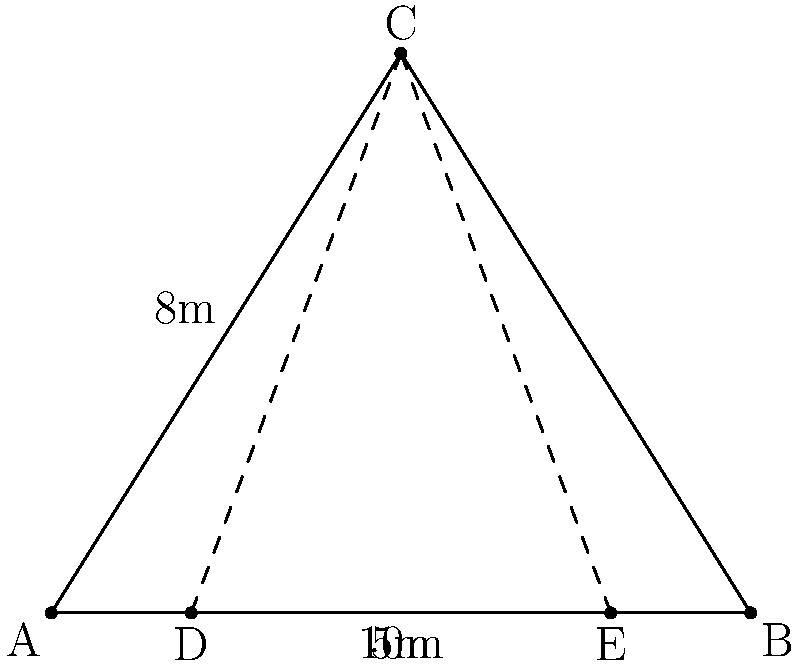In a custom-built car showcase room, a prized vehicle is positioned at point C in an elevated display. The room has a triangular layout with dimensions AB = 10m, AC = 8m, and angle CAB = 90°. Two VIP seats are located at points D and E, 2m from each end of the base. What is the optimal viewing angle DCE for the VIP guests, and how does this setup maximize the visual impact of the showcase? Let's approach this step-by-step:

1) First, we need to find the coordinates of points C, D, and E.
   - A is at (0,0), B at (10,0)
   - C forms a right triangle with AB, so its coordinates are (5,8)
   - D is 2m from A, so it's at (2,0)
   - E is 2m from B, so it's at (8,0)

2) To find angle DCE, we can use the dot product formula:
   $\cos(\theta) = \frac{\vec{CD} \cdot \vec{CE}}{|\vec{CD}||\vec{CE}|}$

3) Calculate vectors $\vec{CD}$ and $\vec{CE}$:
   $\vec{CD} = (2-5, 0-8) = (-3, -8)$
   $\vec{CE} = (8-5, 0-8) = (3, -8)$

4) Calculate dot product $\vec{CD} \cdot \vec{CE}$:
   $(-3)(3) + (-8)(-8) = -9 + 64 = 55$

5) Calculate magnitudes:
   $|\vec{CD}| = |\vec{CE}| = \sqrt{3^2 + 8^2} = \sqrt{73}$

6) Apply the formula:
   $\cos(\theta) = \frac{55}{73} \approx 0.7534$

7) Take the inverse cosine (arccos) to get the angle:
   $\theta = \arccos(0.7534) \approx 0.7217$ radians

8) Convert to degrees:
   $0.7217 \text{ radians} \times \frac{180°}{\pi} \approx 41.3°$

This setup maximizes visual impact by:
- Elevating the car for better visibility
- Providing a wide viewing angle for VIP guests
- Utilizing the room's geometry to create an impressive backdrop
Answer: 41.3° 